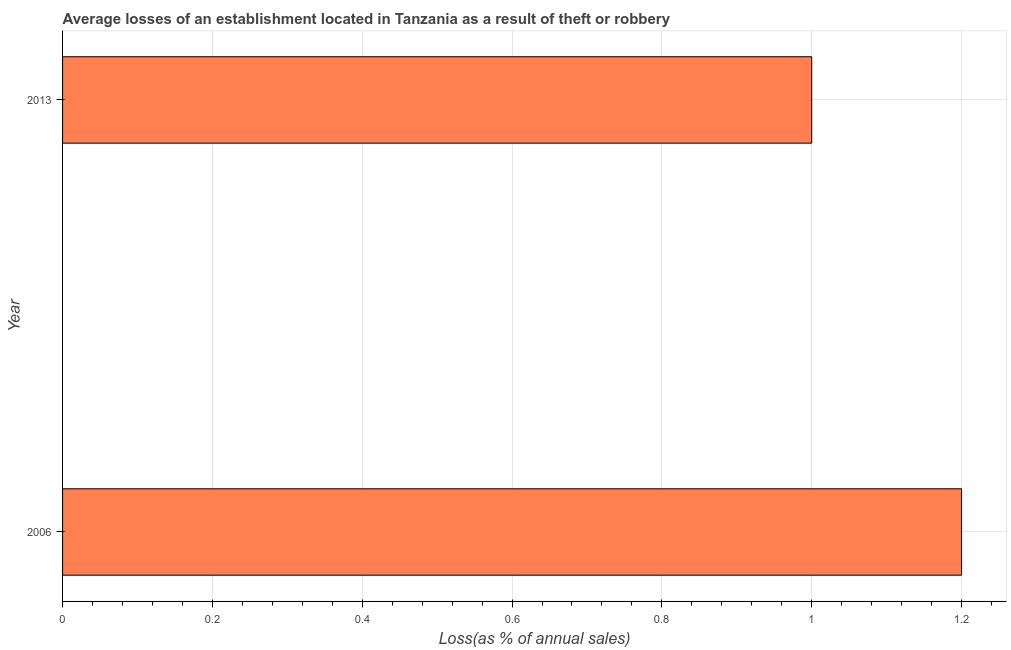Does the graph contain any zero values?
Offer a very short reply. No. What is the title of the graph?
Keep it short and to the point. Average losses of an establishment located in Tanzania as a result of theft or robbery. What is the label or title of the X-axis?
Provide a succinct answer. Loss(as % of annual sales). Across all years, what is the maximum losses due to theft?
Ensure brevity in your answer.  1.2. What is the sum of the losses due to theft?
Provide a succinct answer. 2.2. What is the difference between the losses due to theft in 2006 and 2013?
Offer a very short reply. 0.2. What is the average losses due to theft per year?
Your answer should be compact. 1.1. What is the median losses due to theft?
Ensure brevity in your answer.  1.1. In how many years, is the losses due to theft greater than 0.08 %?
Keep it short and to the point. 2. What is the ratio of the losses due to theft in 2006 to that in 2013?
Your answer should be very brief. 1.2. Is the losses due to theft in 2006 less than that in 2013?
Your answer should be very brief. No. In how many years, is the losses due to theft greater than the average losses due to theft taken over all years?
Your answer should be compact. 1. How many years are there in the graph?
Your answer should be very brief. 2. What is the difference between two consecutive major ticks on the X-axis?
Your answer should be compact. 0.2. What is the Loss(as % of annual sales) in 2006?
Keep it short and to the point. 1.2. What is the Loss(as % of annual sales) of 2013?
Offer a terse response. 1. 